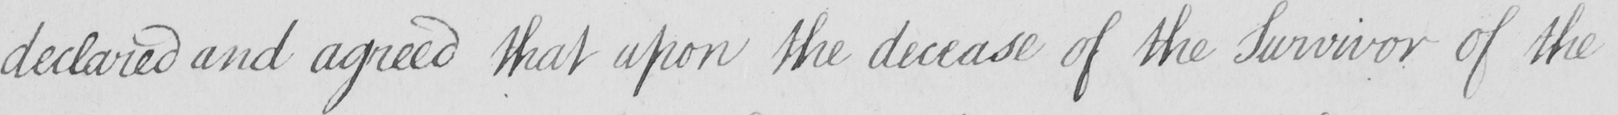What is written in this line of handwriting? declared and agreed that upon the decease of the Survivor of the 